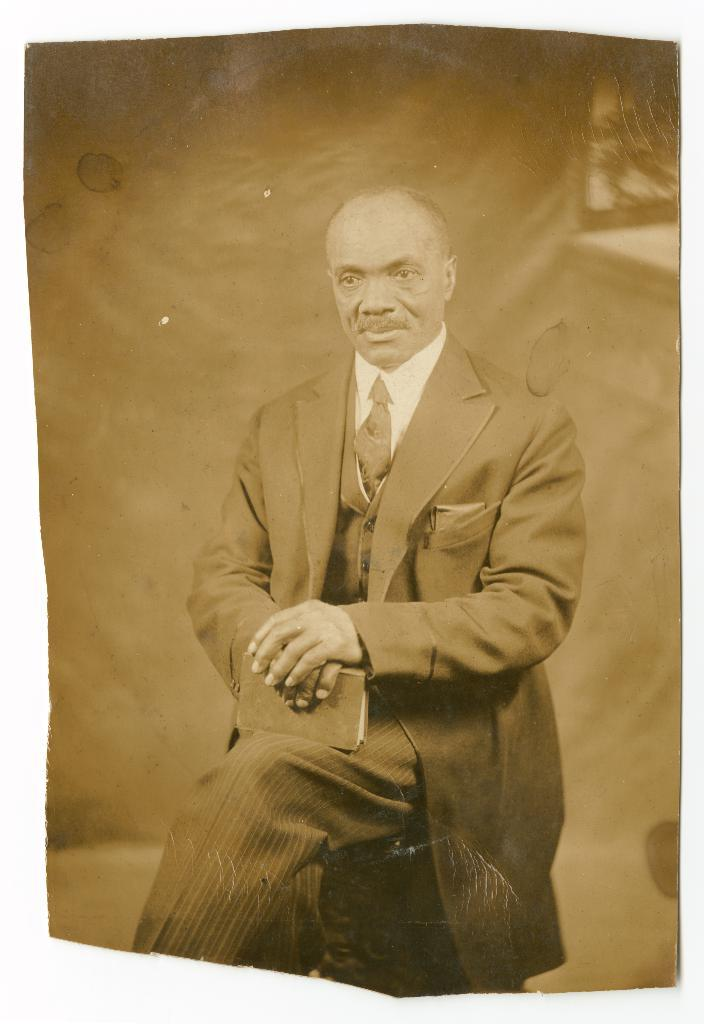What is the main subject of the image? There is a photo of a person in the image. What is the person holding in the image? The person is holding a book. What is the person's position in the image? The person is sitting. What type of tax is being discussed in the image? There is no mention of tax or any discussion in the image; it features a person holding a book while sitting. 